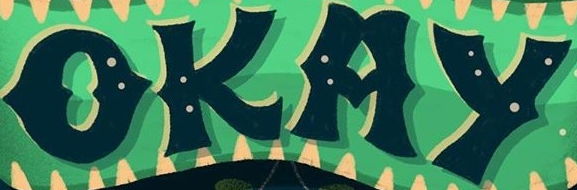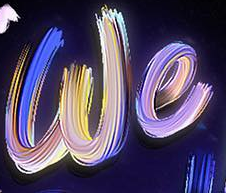What words are shown in these images in order, separated by a semicolon? OKAY; we 